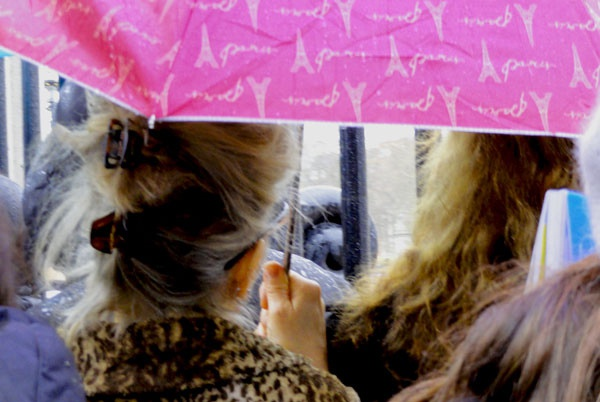Describe the objects in this image and their specific colors. I can see umbrella in violet and lavender tones, people in violet, black, maroon, and gray tones, people in violet, black, maroon, olive, and tan tones, people in violet, gray, and black tones, and book in violet, lavender, lightblue, and darkgray tones in this image. 